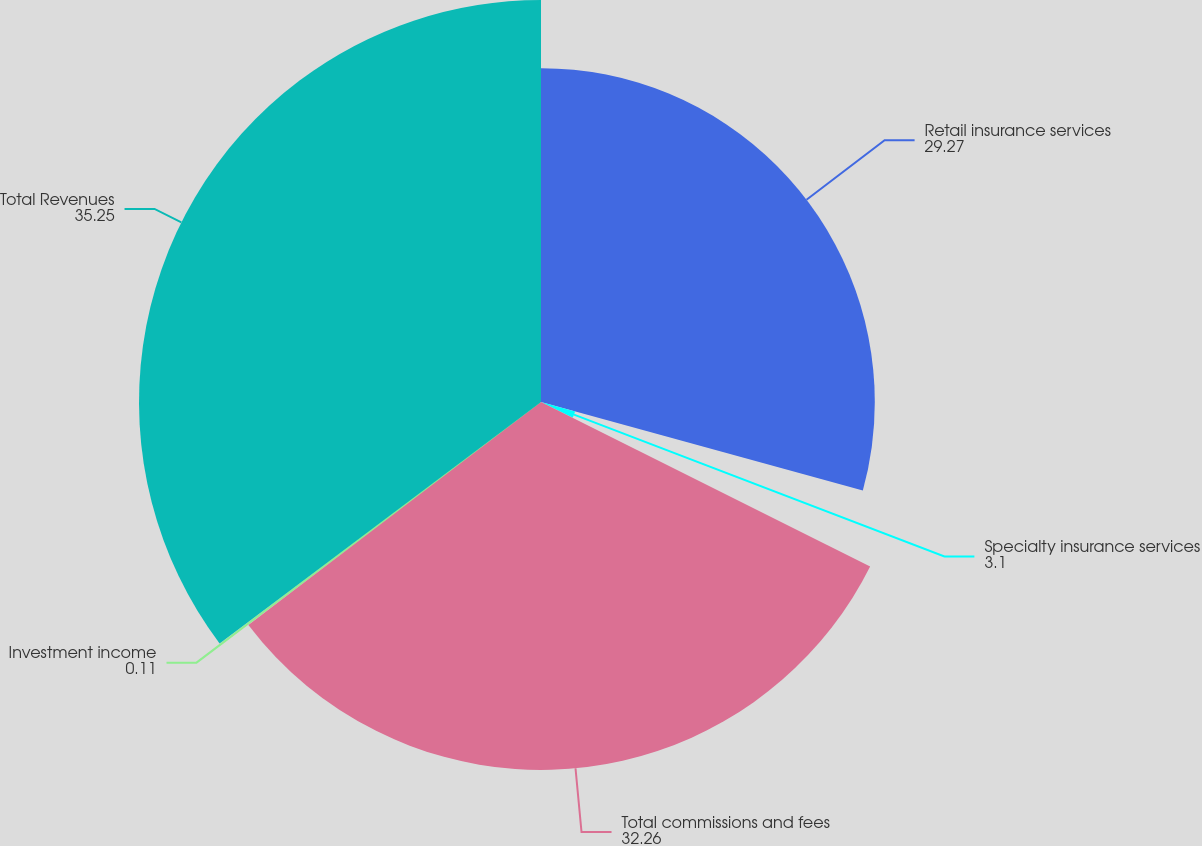Convert chart. <chart><loc_0><loc_0><loc_500><loc_500><pie_chart><fcel>Retail insurance services<fcel>Specialty insurance services<fcel>Total commissions and fees<fcel>Investment income<fcel>Total Revenues<nl><fcel>29.27%<fcel>3.1%<fcel>32.26%<fcel>0.11%<fcel>35.25%<nl></chart> 